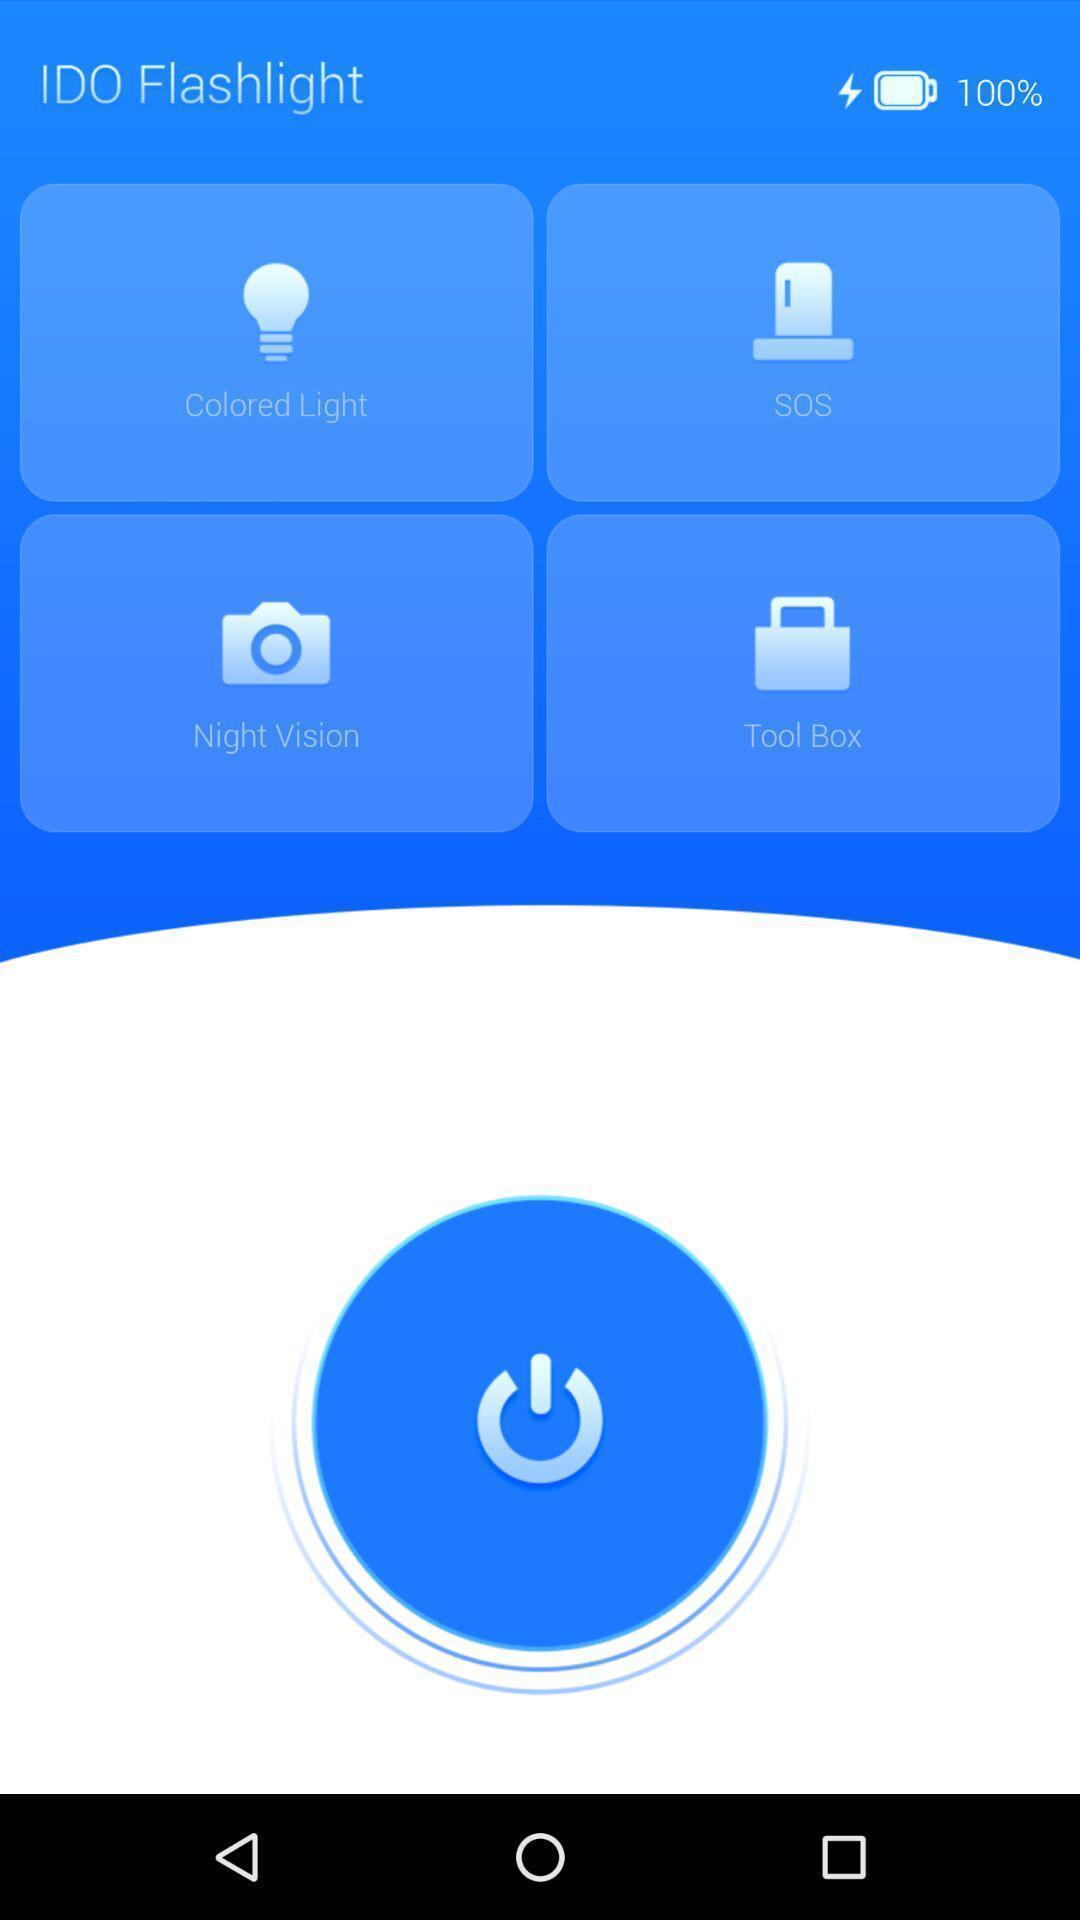Explain the elements present in this screenshot. Start page of camera app with different options. 